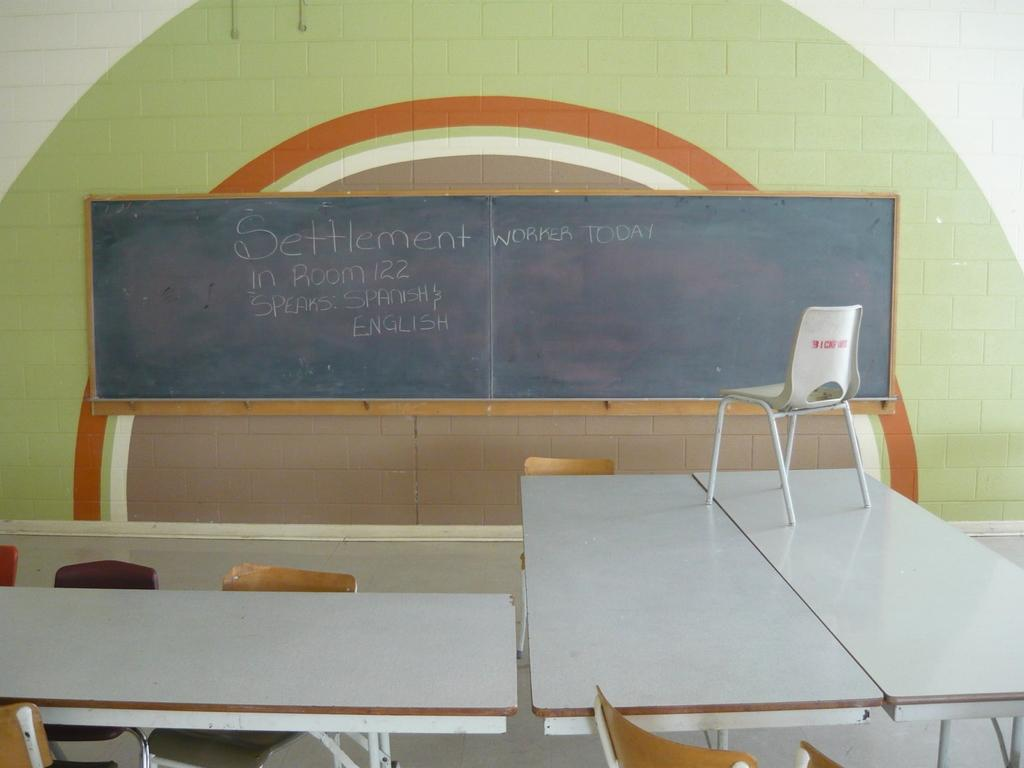<image>
Present a compact description of the photo's key features. the blackboard displaying message 'settlement worker today in room 122' 